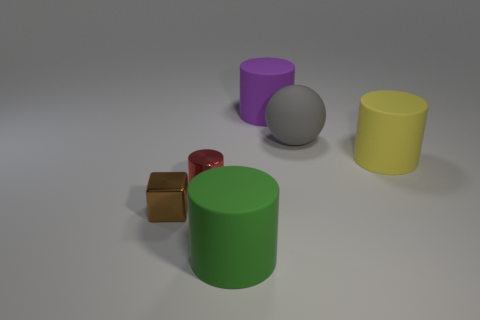Are there fewer purple cylinders behind the purple rubber cylinder than tiny green metal objects?
Keep it short and to the point. No. Is the metallic block the same color as the matte sphere?
Give a very brief answer. No. What is the size of the yellow matte thing that is the same shape as the red object?
Offer a very short reply. Large. What number of cyan cubes have the same material as the big green cylinder?
Ensure brevity in your answer.  0. Is the thing on the left side of the small red shiny thing made of the same material as the gray ball?
Make the answer very short. No. Are there an equal number of big matte cylinders in front of the metallic cylinder and brown matte cubes?
Your response must be concise. No. The purple cylinder is what size?
Your response must be concise. Large. How many tiny cubes have the same color as the metal cylinder?
Your answer should be very brief. 0. Is the gray sphere the same size as the green cylinder?
Provide a succinct answer. Yes. There is a cylinder that is in front of the tiny shiny thing in front of the small red shiny cylinder; what is its size?
Provide a short and direct response. Large. 